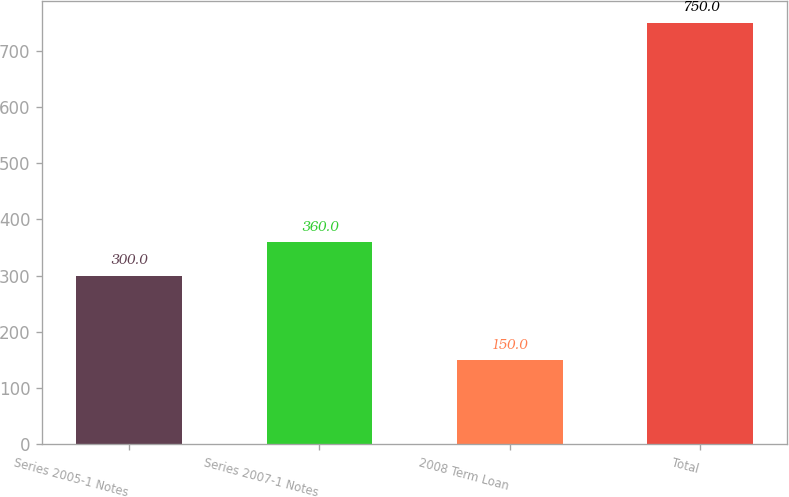<chart> <loc_0><loc_0><loc_500><loc_500><bar_chart><fcel>Series 2005-1 Notes<fcel>Series 2007-1 Notes<fcel>2008 Term Loan<fcel>Total<nl><fcel>300<fcel>360<fcel>150<fcel>750<nl></chart> 